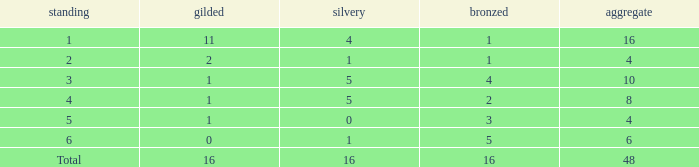What is the total gold that has bronze less than 2, a silver of 1 and total more than 4? None. 